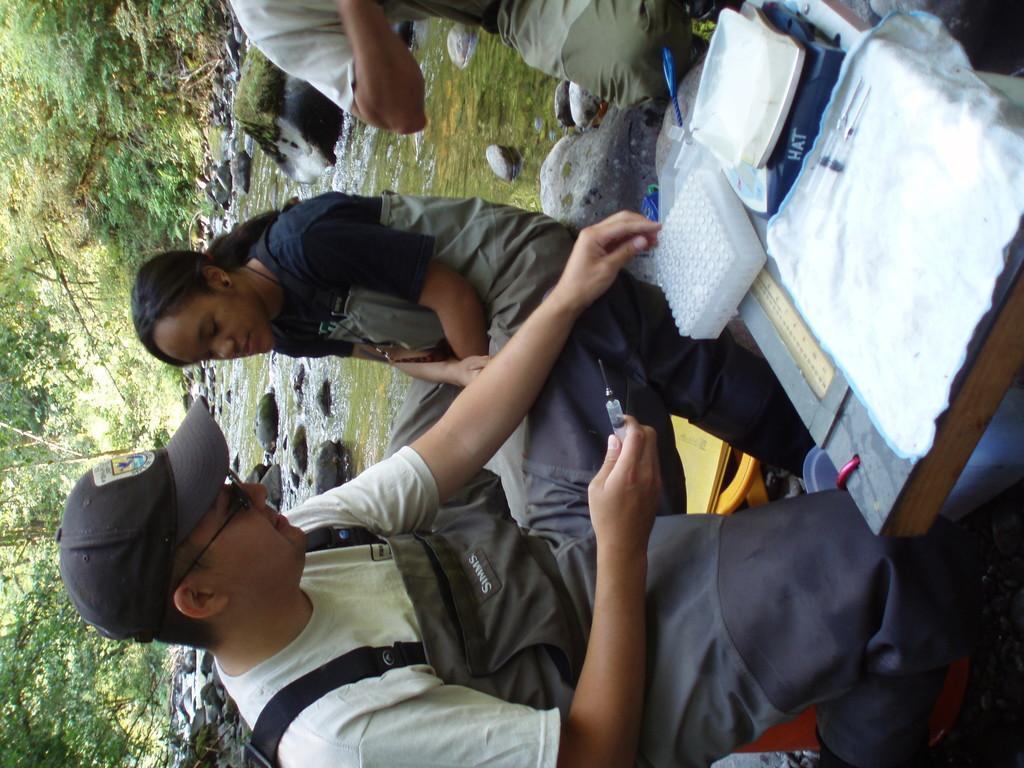How would you summarize this image in a sentence or two? In this image I can see three people with different color dresses and aprons. I can see one person wearing the cap. There is a table in-front of these people. I can see many objects on the table. I can also see the person holding the injection. In the background I can see the water, rocks and the trees. 